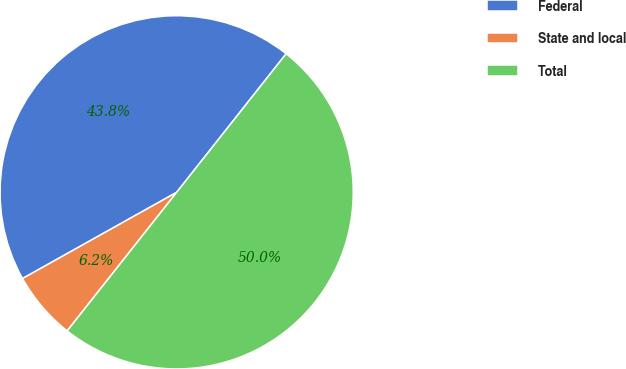<chart> <loc_0><loc_0><loc_500><loc_500><pie_chart><fcel>Federal<fcel>State and local<fcel>Total<nl><fcel>43.76%<fcel>6.24%<fcel>50.0%<nl></chart> 